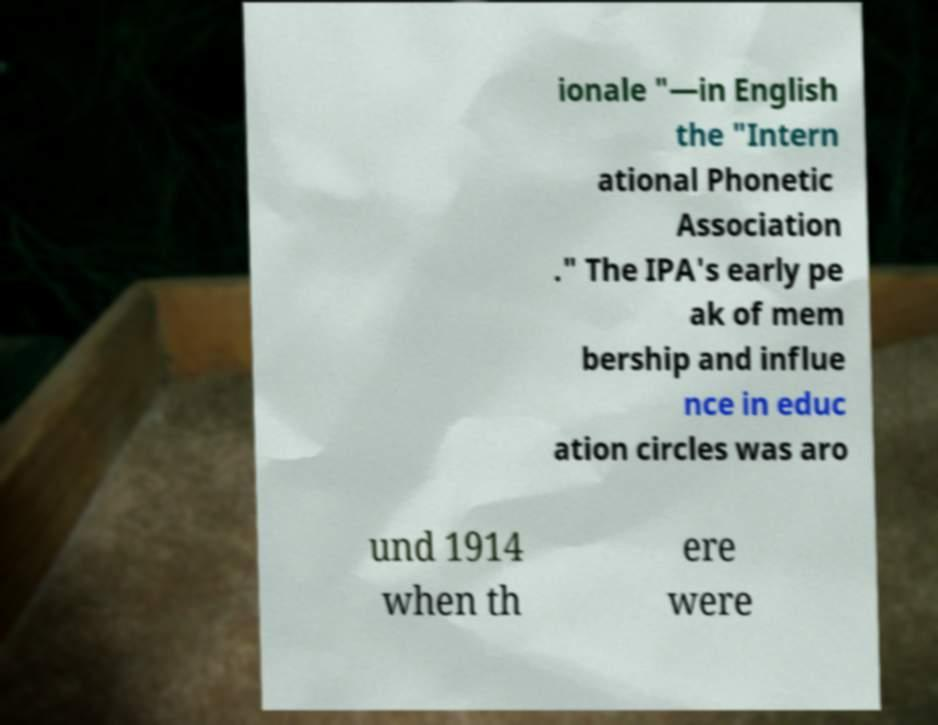Could you assist in decoding the text presented in this image and type it out clearly? ionale "—in English the "Intern ational Phonetic Association ." The IPA's early pe ak of mem bership and influe nce in educ ation circles was aro und 1914 when th ere were 